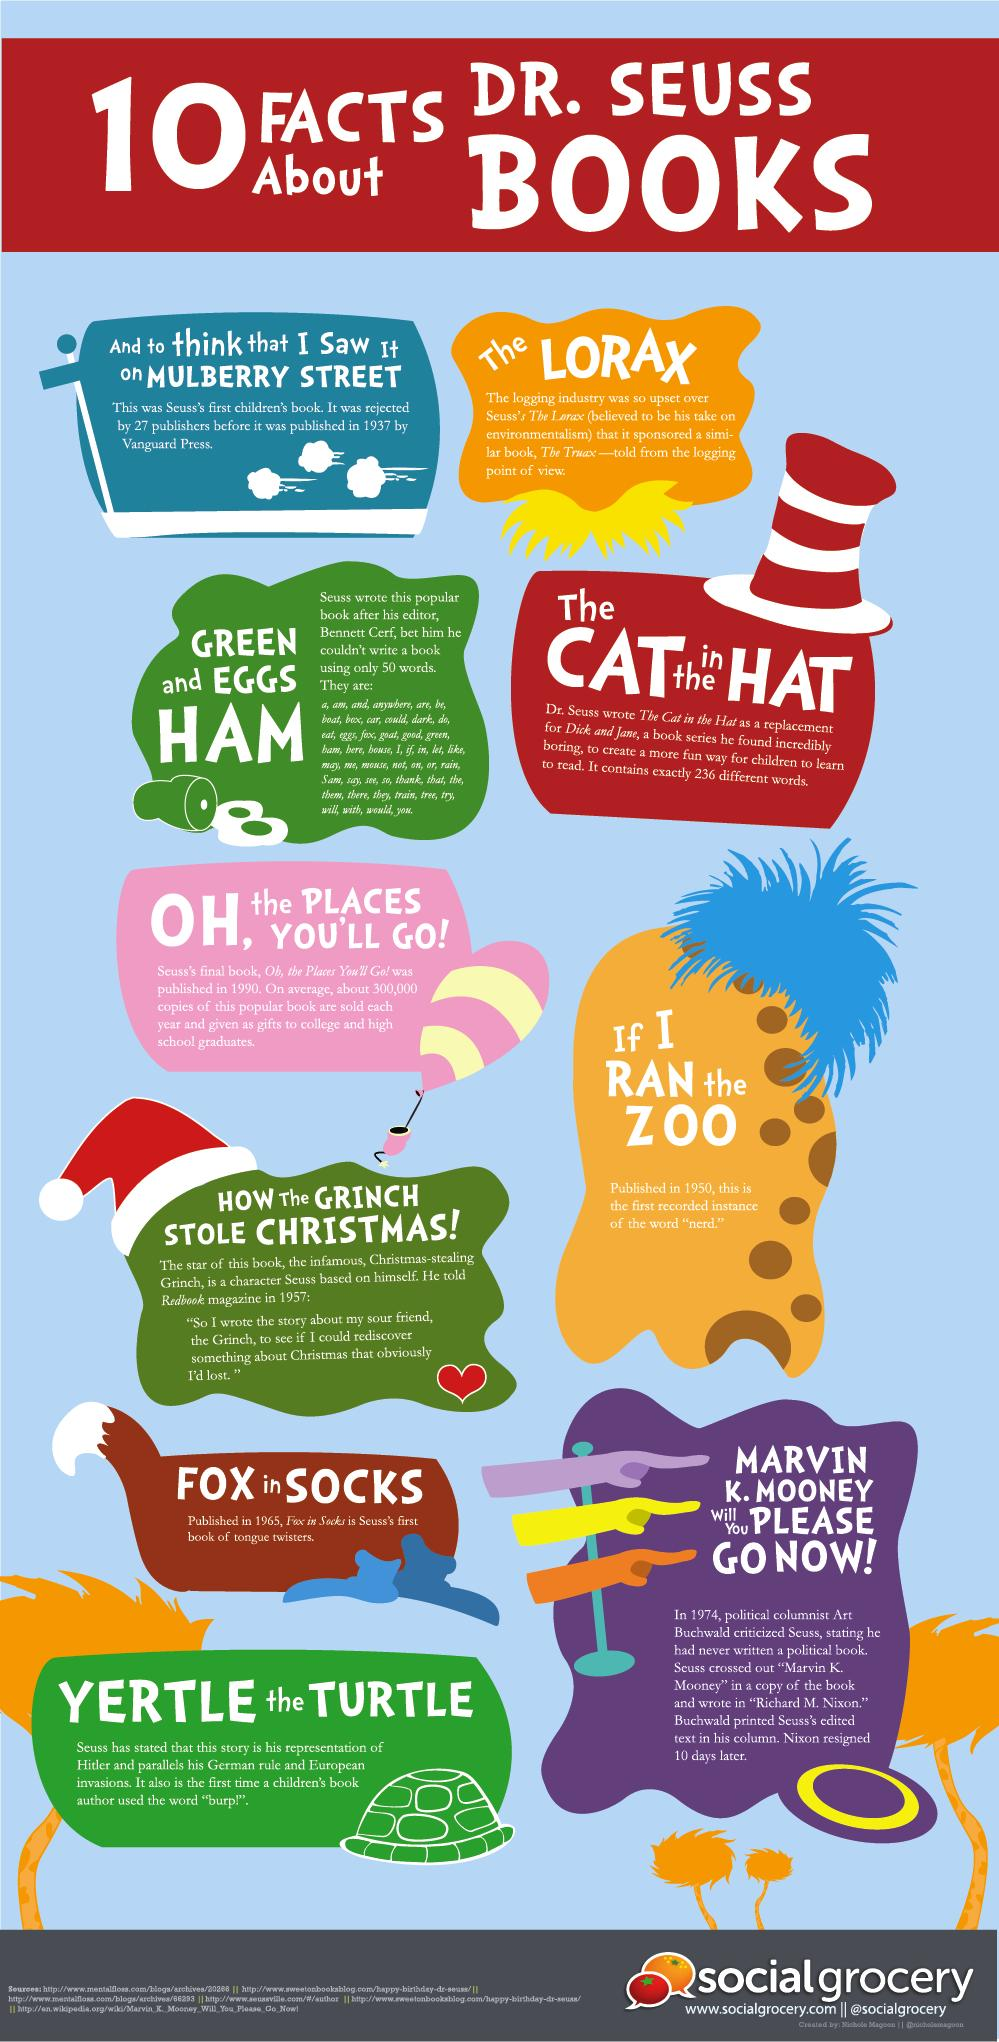Point out several critical features in this image. The author's first book was printed in 1937. The book "The Lorax," written by Dr. Seuss, does not support the timber business. There are three Dr. Seuss books with animal names on their titles. 